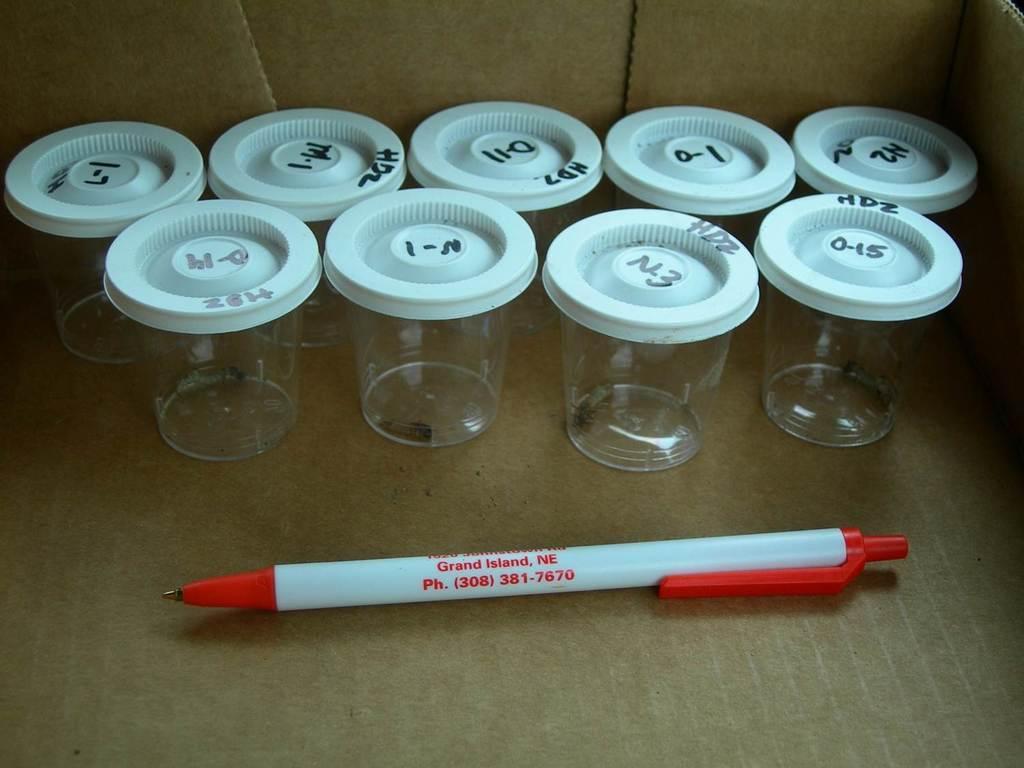In one or two sentences, can you explain what this image depicts? This picture is taken inside the box. In the middle of the box, we can see a pen. In the background of the box, we can see some glasses closed with a cap. 